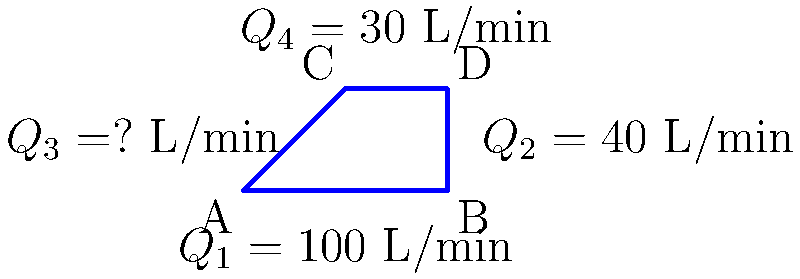In the pipe network shown above, water flows from point A to points B, C, and D. Given that the total flow rate at point A ($Q_1$) is 100 L/min, the flow rate to point B ($Q_2$) is 40 L/min, and the flow rate to point C ($Q_4$) is 30 L/min, determine the flow rate to point D ($Q_3$) in L/min. To solve this problem, we'll use the principle of conservation of mass, which states that the total flow rate entering a junction must equal the total flow rate leaving the junction. In this case, we'll apply this principle to point A.

Step 1: Identify the known flow rates
- Total flow rate at A: $Q_1 = 100$ L/min
- Flow rate to B: $Q_2 = 40$ L/min
- Flow rate to C: $Q_4 = 30$ L/min

Step 2: Set up the conservation of mass equation
$$Q_1 = Q_2 + Q_3 + Q_4$$

Step 3: Substitute the known values
$$100 = 40 + Q_3 + 30$$

Step 4: Solve for $Q_3$
$$Q_3 = 100 - 40 - 30 = 30$$

Therefore, the flow rate to point D ($Q_3$) is 30 L/min.
Answer: 30 L/min 